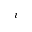Convert formula to latex. <formula><loc_0><loc_0><loc_500><loc_500>i</formula> 